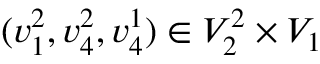<formula> <loc_0><loc_0><loc_500><loc_500>( v _ { 1 } ^ { 2 } , v _ { 4 } ^ { 2 } , v _ { 4 } ^ { 1 } ) \in V _ { 2 } ^ { 2 } \times V _ { 1 }</formula> 